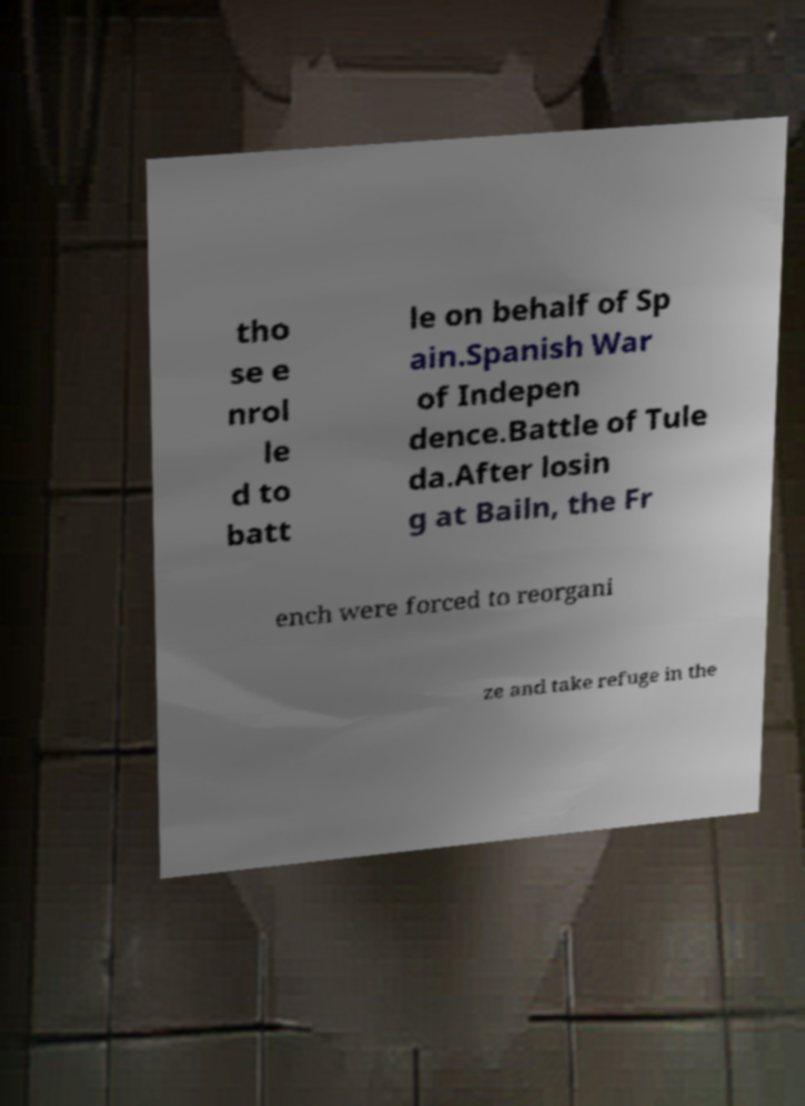Can you accurately transcribe the text from the provided image for me? tho se e nrol le d to batt le on behalf of Sp ain.Spanish War of Indepen dence.Battle of Tule da.After losin g at Bailn, the Fr ench were forced to reorgani ze and take refuge in the 